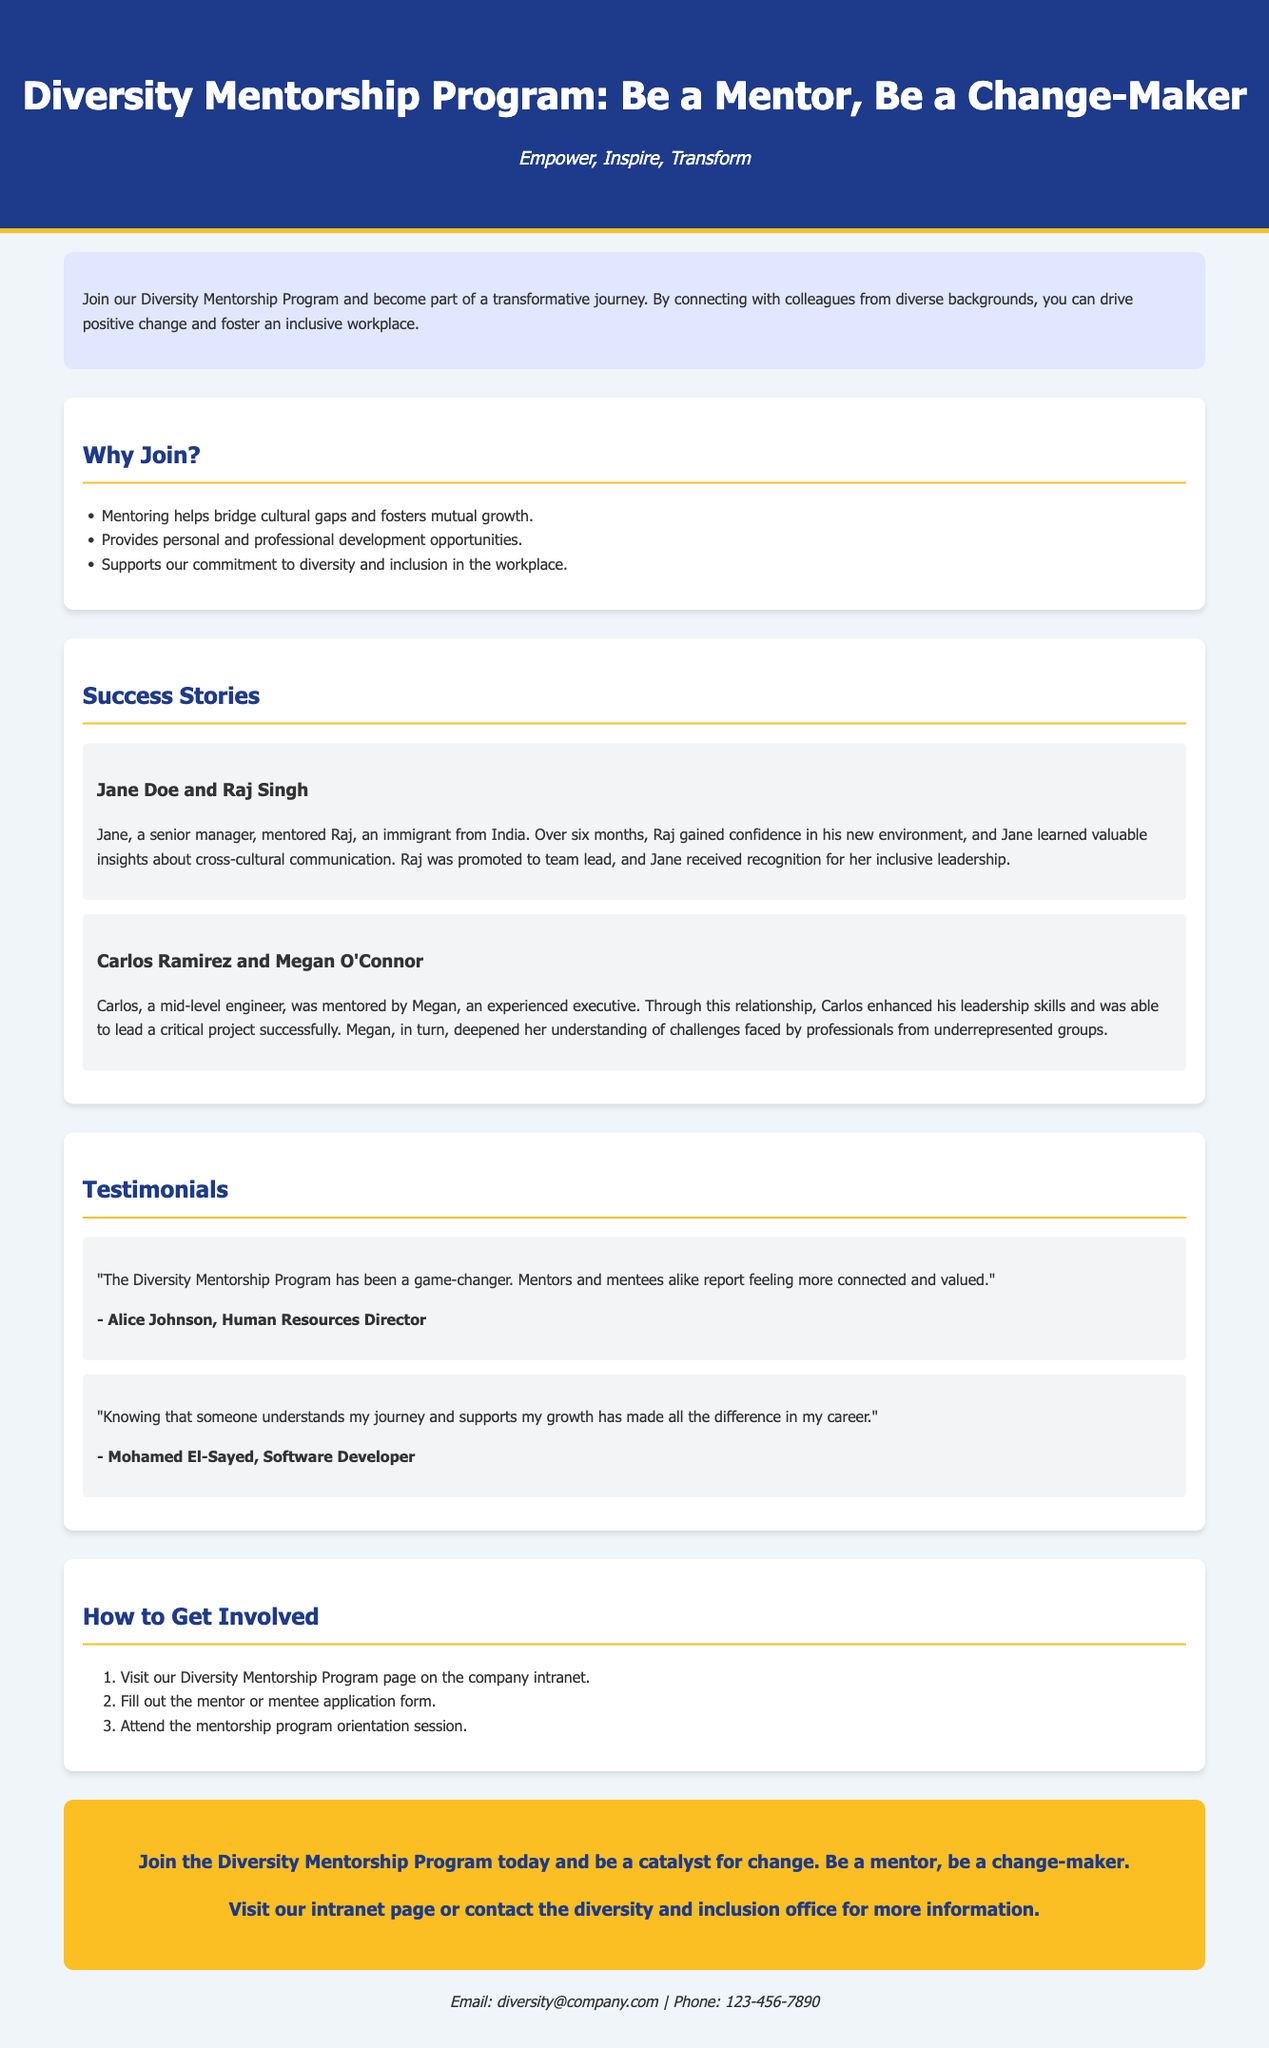What is the title of the program? The title of the program is prominently displayed in the header section of the document.
Answer: Diversity Mentorship Program: Be a Mentor, Be a Change-Maker Who is the Human Resources Director mentioned in the testimonials? The human resources director is quoted in the testimonials section, providing feedback about the program.
Answer: Alice Johnson What does the introductory paragraph encourage participants to do? The introductory paragraph outlines the purpose and transformative potential of the program.
Answer: Join our Diversity Mentorship Program How many success stories are highlighted in the document? The document features a section specifically dedicated to showcasing success stories, where achievements of mentor-mentee pairs are detailed.
Answer: 2 What is the first step to get involved in the program? The document lists specific steps for participation in the mentorship program.
Answer: Visit our Diversity Mentorship Program page on the company intranet What is the background color of the call-to-action section? The call-to-action section is visually distinct and contains an engaging message about joining the program.
Answer: #fbbf24 What key quality does mentoring promote according to the document? The document includes a list of benefits associated with mentoring, emphasizing its impact on workplace culture.
Answer: Mutual growth What is the contact email provided for more information? The document offers contact details at the bottom for inquiries related to the program.
Answer: diversity@company.com 